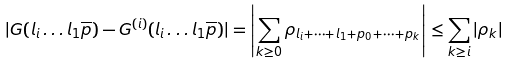<formula> <loc_0><loc_0><loc_500><loc_500>| G ( l _ { i } \dots l _ { 1 } \overline { p } ) - G ^ { ( i ) } ( l _ { i } \dots l _ { 1 } \overline { p } ) | = \left | \sum _ { k \geq 0 } \rho _ { l _ { i } + \dots + l _ { 1 } + p _ { 0 } + \dots + p _ { k } } \right | \leq \sum _ { k \geq i } | \rho _ { k } |</formula> 